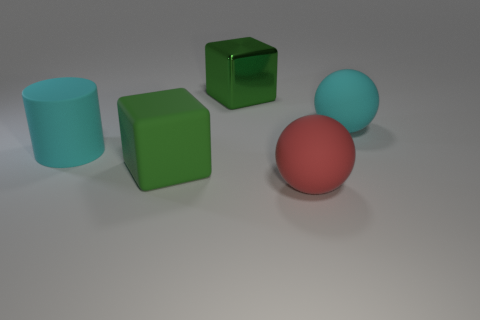Subtract all cyan spheres. How many spheres are left? 1 Add 4 large cylinders. How many objects exist? 9 Subtract all purple balls. Subtract all purple cubes. How many balls are left? 2 Add 5 large metallic objects. How many large metallic objects are left? 6 Add 2 big red spheres. How many big red spheres exist? 3 Subtract 1 cyan cylinders. How many objects are left? 4 Subtract all spheres. How many objects are left? 3 Subtract all brown cubes. How many blue balls are left? 0 Subtract all big green matte objects. Subtract all balls. How many objects are left? 2 